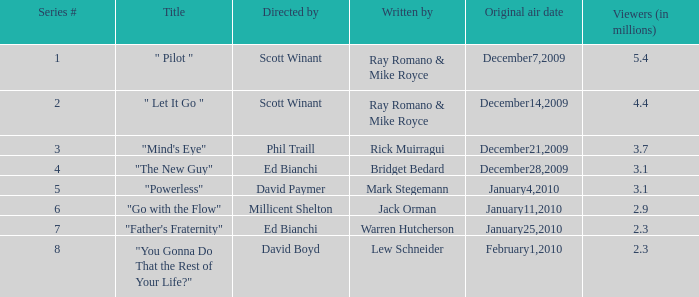How many viewers (in millions) did episode 1 have? 5.4. 